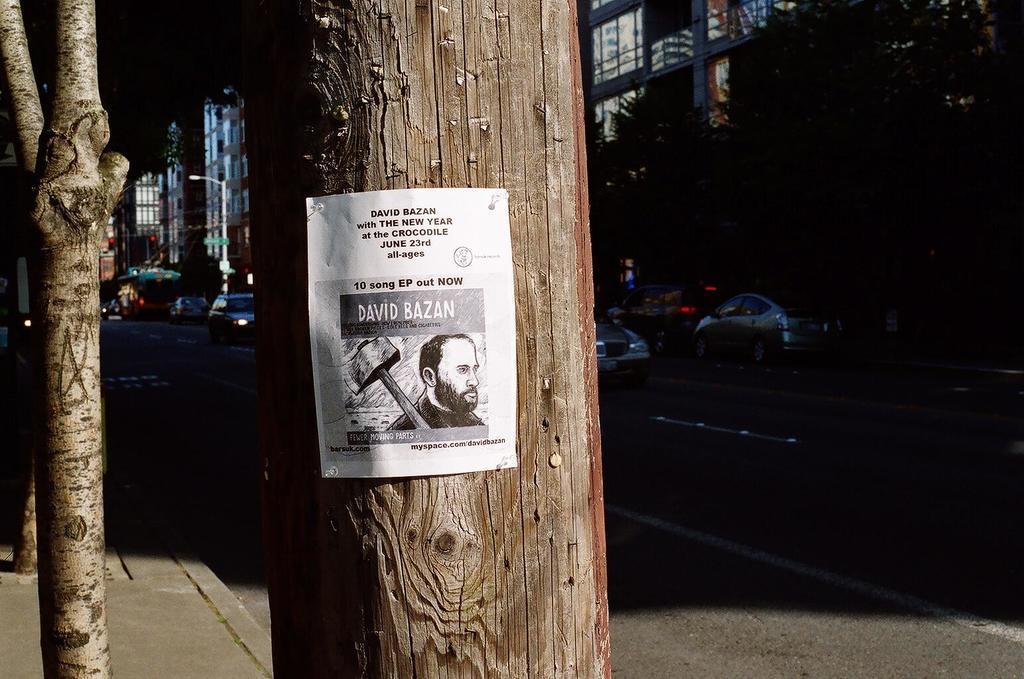How would you summarize this image in a sentence or two? In this image we can see there is a poster attached to the trunk of a tree, behind the tree there are cars passing on the road, on the other side of the road their buildings and lamp posts. 